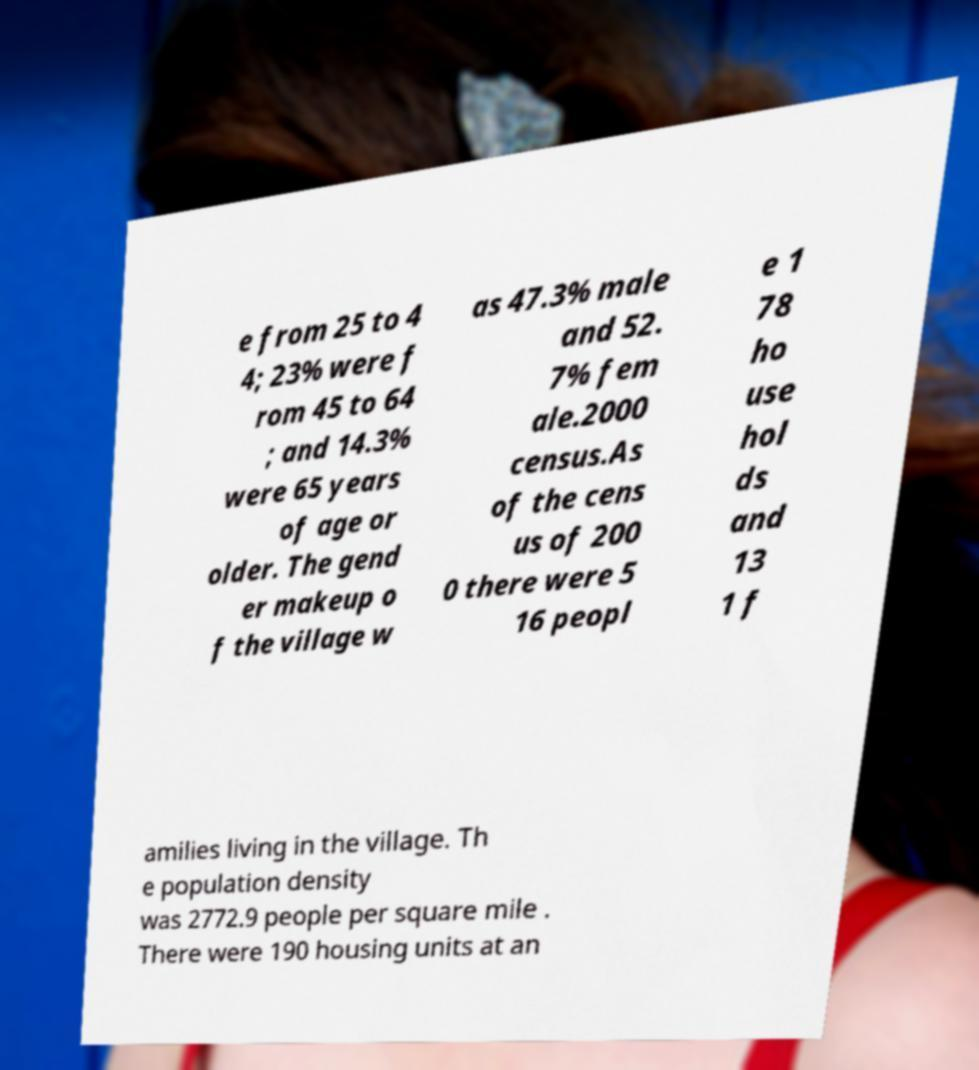Could you assist in decoding the text presented in this image and type it out clearly? e from 25 to 4 4; 23% were f rom 45 to 64 ; and 14.3% were 65 years of age or older. The gend er makeup o f the village w as 47.3% male and 52. 7% fem ale.2000 census.As of the cens us of 200 0 there were 5 16 peopl e 1 78 ho use hol ds and 13 1 f amilies living in the village. Th e population density was 2772.9 people per square mile . There were 190 housing units at an 